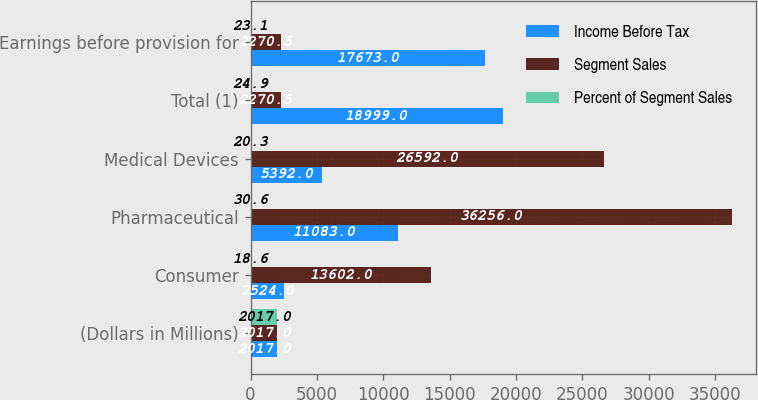<chart> <loc_0><loc_0><loc_500><loc_500><stacked_bar_chart><ecel><fcel>(Dollars in Millions)<fcel>Consumer<fcel>Pharmaceutical<fcel>Medical Devices<fcel>Total (1)<fcel>Earnings before provision for<nl><fcel>Income Before Tax<fcel>2017<fcel>2524<fcel>11083<fcel>5392<fcel>18999<fcel>17673<nl><fcel>Segment Sales<fcel>2017<fcel>13602<fcel>36256<fcel>26592<fcel>2270.5<fcel>2270.5<nl><fcel>Percent of Segment Sales<fcel>2017<fcel>18.6<fcel>30.6<fcel>20.3<fcel>24.9<fcel>23.1<nl></chart> 